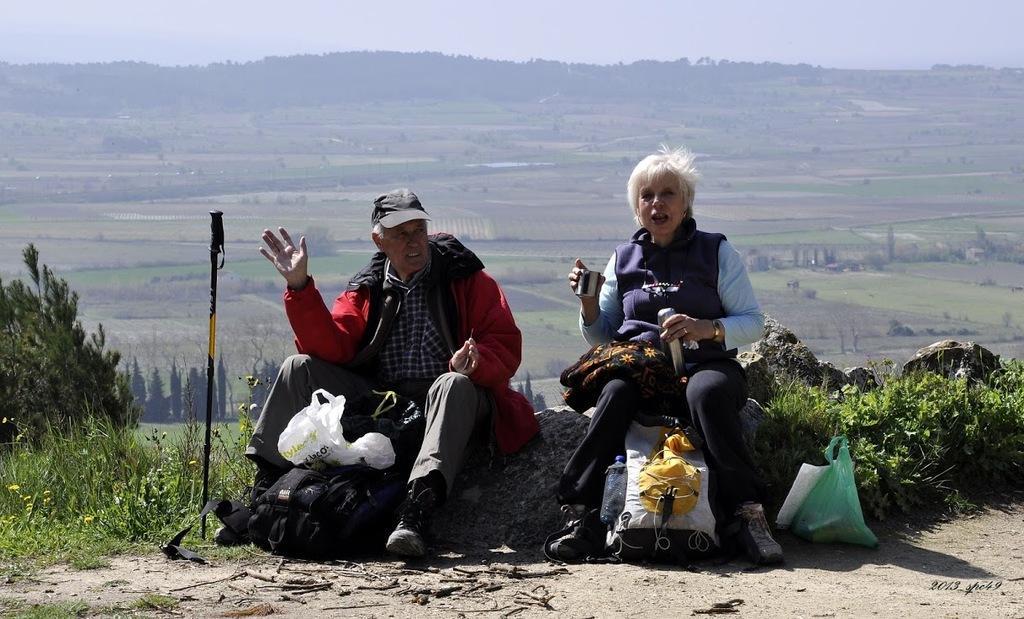How would you summarize this image in a sentence or two? In this image in the center there is one man and one woman who are sitting and that woman is holding a flask and one glass, and also she is holding bags beside them there are some bags and plastic covers. And at the bottom there are some plants, grass and mountains. In the background there are some trees, on the top of the image there is sky. 